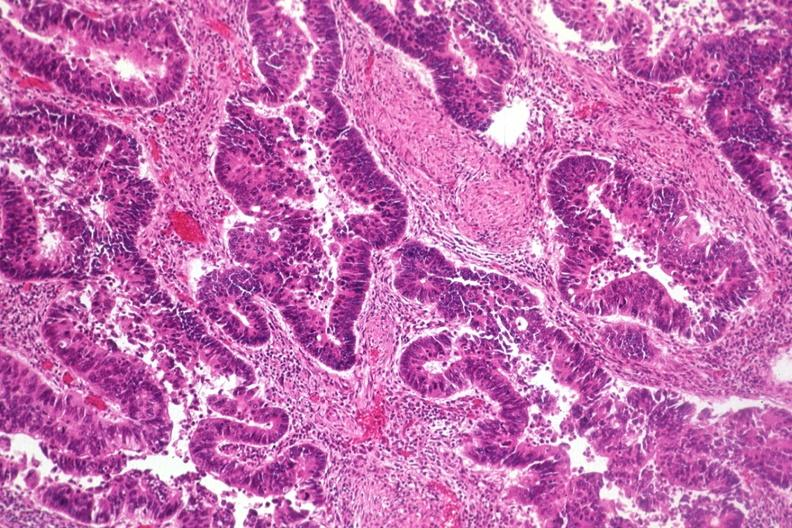does amyloid angiopathy r. endocrine show typical histology for colon adenocarcinoma?
Answer the question using a single word or phrase. No 